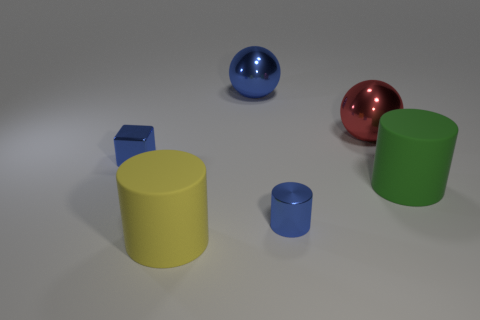If these objects were part of a game, what could their purpose be? Imagining a game scenario, the different shapes and colors of the objects could serve as pieces in a sorting or matching game. The objective might be to group objects by color or shape, or perhaps the reflective objects could be 'prized' pieces that offer additional points. The diversity of forms allows for several engaging possibilities. 